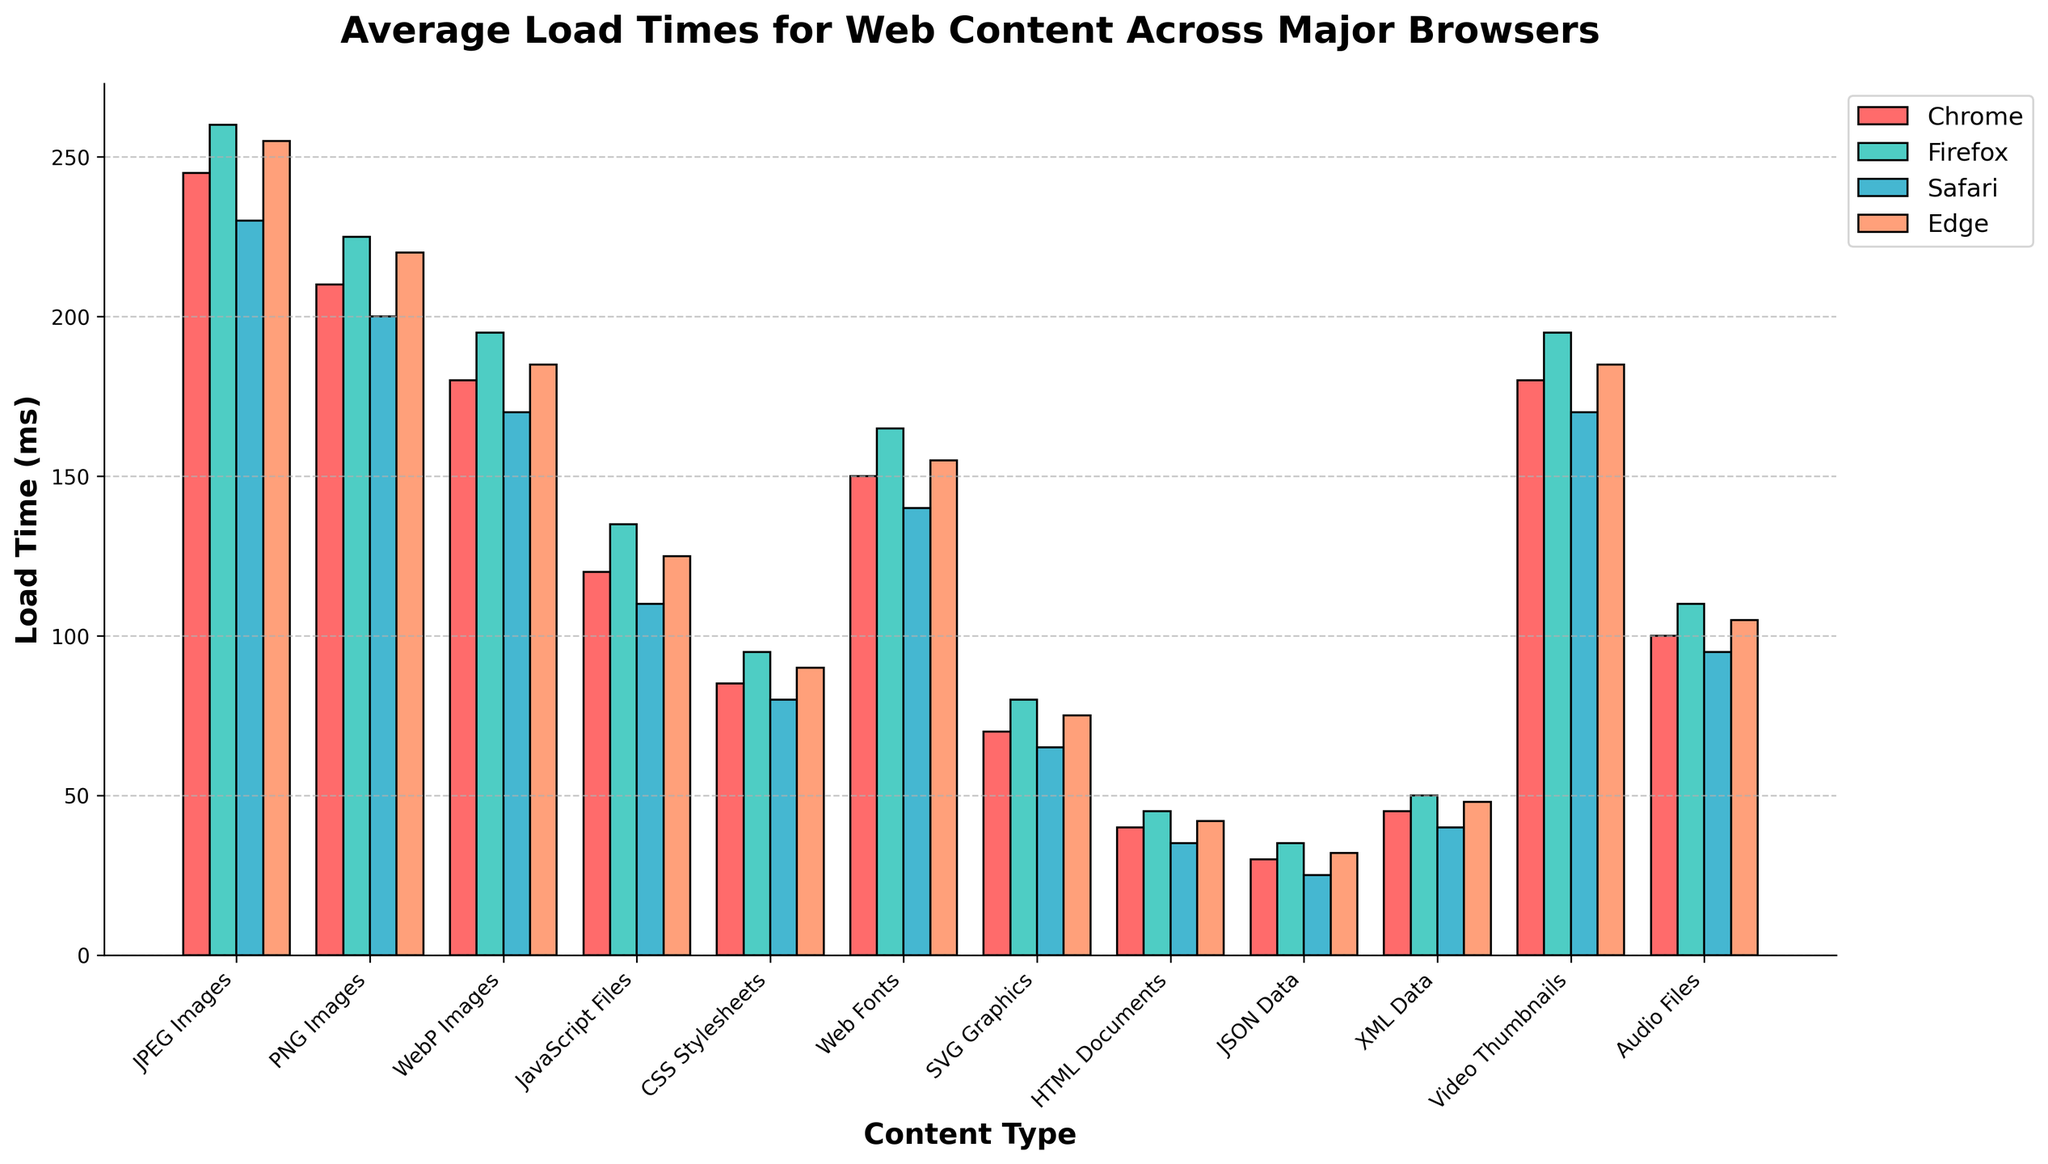Which browser has the fastest average load time for PNG Images? To determine the fastest load time, you need to identify the shortest bar for PNG Images. The shortest bar corresponds to Safari with a load time of 200 ms.
Answer: Safari Which content type has the greatest load time difference between Chrome and Edge? Look for the content type where the difference in height of the bars for Chrome and Edge is the greatest. For JPEG Images, the load time difference is 245 ms (Chrome) - 255 ms (Edge) = 10 ms. PNG Images have 210 ms (Chrome) - 220 ms (Edge) = 10 ms. For JavaScript Files, it is 120 ms (Chrome) - 125 ms (Edge) = 5 ms. CSS Stylesheets have 85 ms (Chrome) - 90 ms (Edge) = 5 ms. Web Fonts have 150 ms (Chrome) - 155 ms (Edge) = 5 ms. SVG Graphics have 70 ms (Chrome) - 75 ms (Edge) = 5 ms. HTML Documents have 40 ms (Chrome) - 42 ms (Edge) = 2 ms. JSON Data has 30 ms (Chrome) - 32 ms (Edge) = 2 ms. XML Data has 45 ms (Chrome) - 48 ms (Edge) = 3 ms. Video Thumbnails have 180 ms (Chrome) - 185 ms (Edge) = 5 ms. Audio Files have 100 ms (Chrome) - 105 ms (Edge) = 5 ms. Thus, PNG Images and JPEG Images have the greatest difference of 10 ms.
Answer: JPEG Images or PNG Images What's the average load time for Web Fonts across all browsers? Add the load times for Web Fonts across all browsers and divide by the number of browsers. The sum is 150 (Chrome) + 165 (Firefox) + 140 (Safari) + 155 (Edge) = 610 ms. The average is 610 ms / 4 = 152.5 ms.
Answer: 152.5 ms Which content type takes the least time to load on Chrome? Identify the shortest bar among all content types for Chrome. HTML Documents with a load time of 40 ms has the shortest bar.
Answer: HTML Documents Which browser generally performs better for Audio Files based on the load times? Compare the bar heights for Audio Files across all browsers. Safari has the shortest bar for Audio Files at 95 ms, indicating the fastest load time.
Answer: Safari What is the total load time for JavaScript Files and CSS Stylesheets on Firefox? Sum the load times for JavaScript Files (135 ms) and CSS Stylesheets (95 ms) on Firefox. The total is 135 ms + 95 ms = 230 ms.
Answer: 230 ms Is there a browser that consistently shows the second-fastest load time for different types of web content? Compare the bar heights for the second shortest bars across various content types for each browser. Observation reveals that Safari frequently has the second-shortest bars, indicating it consistently shows the second-fastest load times across multiple content types.
Answer: Safari Which content type does Firefox load faster than all the other browsers? Check for the content type where Firefox's bar is the shortest compared to the other browsers. There is no such content type where Firefox is faster than all other browsers.
Answer: None 